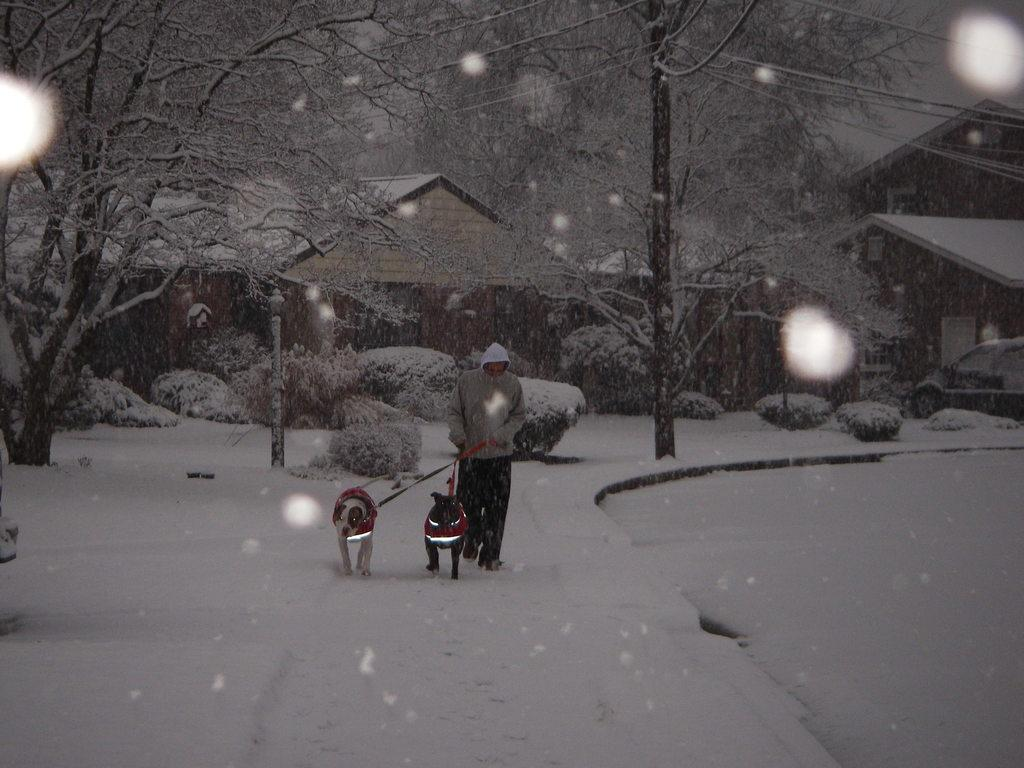Who or what is present in the image? There is a person and two dogs in the image. What are the person and dogs doing in the image? The person and dogs are walking on snow. What can be seen in the background of the image? There are trees, houses, and a car in the background of the image. What type of books can be seen in the image? There are no books present in the image. How many people are in the crowd in the image? There is no crowd present in the image. 